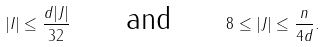<formula> <loc_0><loc_0><loc_500><loc_500>| I | \leq \frac { d | J | } { 3 2 } \quad \text { \ and \ } \quad 8 \leq | J | \leq \frac { n } { 4 d } .</formula> 